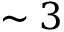Convert formula to latex. <formula><loc_0><loc_0><loc_500><loc_500>\sim 3</formula> 